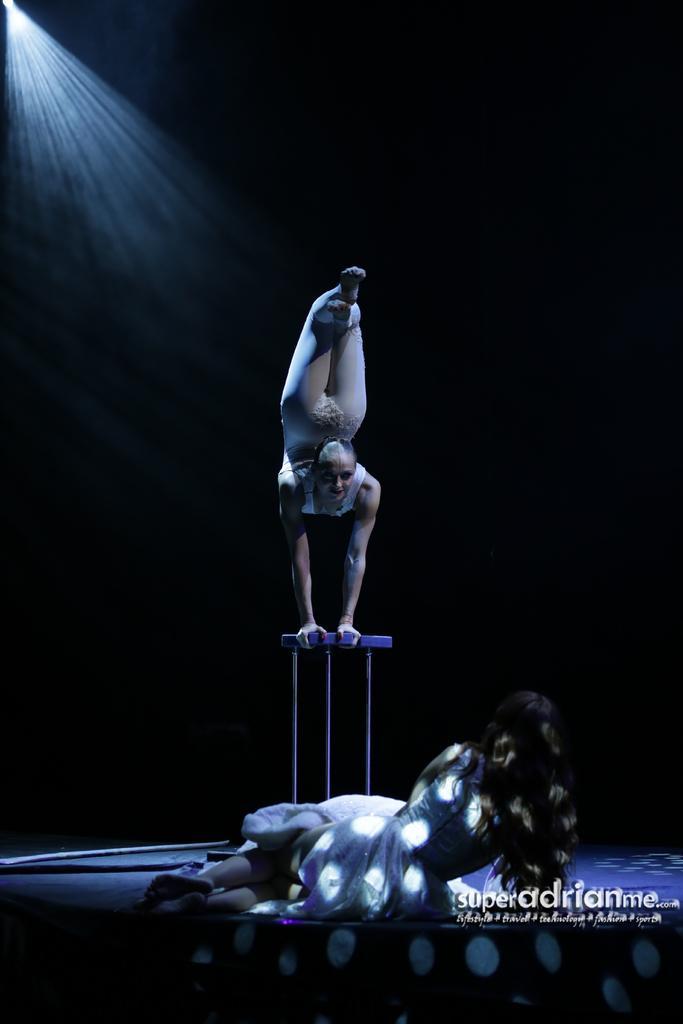Describe this image in one or two sentences. In this image there is a woman doing gymnastics on the stool. In front of her there is a woman lying on the floor. The background is dark. In the top left there is a light. In the bottom right there is text on the image. 